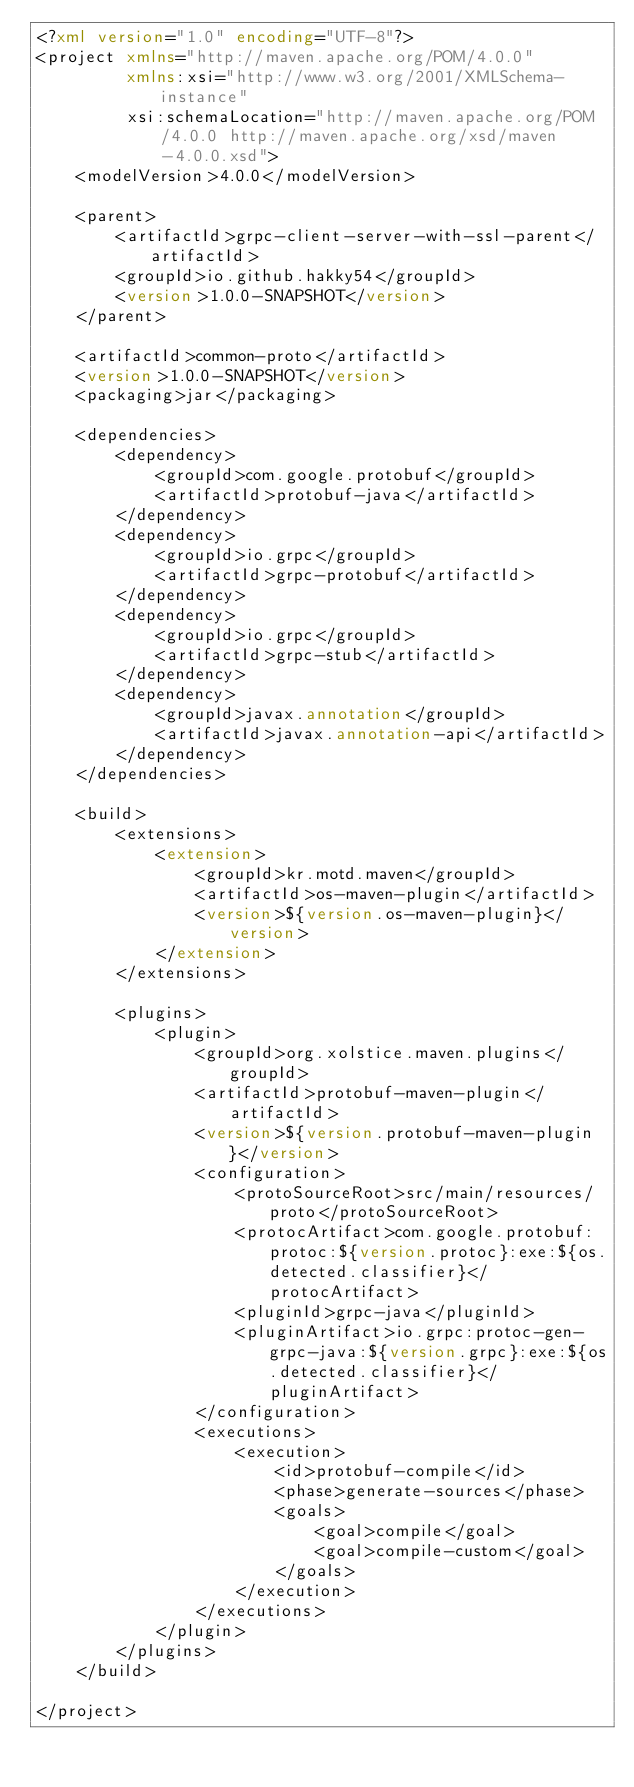Convert code to text. <code><loc_0><loc_0><loc_500><loc_500><_XML_><?xml version="1.0" encoding="UTF-8"?>
<project xmlns="http://maven.apache.org/POM/4.0.0"
         xmlns:xsi="http://www.w3.org/2001/XMLSchema-instance"
         xsi:schemaLocation="http://maven.apache.org/POM/4.0.0 http://maven.apache.org/xsd/maven-4.0.0.xsd">
    <modelVersion>4.0.0</modelVersion>

    <parent>
        <artifactId>grpc-client-server-with-ssl-parent</artifactId>
        <groupId>io.github.hakky54</groupId>
        <version>1.0.0-SNAPSHOT</version>
    </parent>

    <artifactId>common-proto</artifactId>
    <version>1.0.0-SNAPSHOT</version>
    <packaging>jar</packaging>

    <dependencies>
        <dependency>
            <groupId>com.google.protobuf</groupId>
            <artifactId>protobuf-java</artifactId>
        </dependency>
        <dependency>
            <groupId>io.grpc</groupId>
            <artifactId>grpc-protobuf</artifactId>
        </dependency>
        <dependency>
            <groupId>io.grpc</groupId>
            <artifactId>grpc-stub</artifactId>
        </dependency>
        <dependency>
            <groupId>javax.annotation</groupId>
            <artifactId>javax.annotation-api</artifactId>
        </dependency>
    </dependencies>

    <build>
        <extensions>
            <extension>
                <groupId>kr.motd.maven</groupId>
                <artifactId>os-maven-plugin</artifactId>
                <version>${version.os-maven-plugin}</version>
            </extension>
        </extensions>

        <plugins>
            <plugin>
                <groupId>org.xolstice.maven.plugins</groupId>
                <artifactId>protobuf-maven-plugin</artifactId>
                <version>${version.protobuf-maven-plugin}</version>
                <configuration>
                    <protoSourceRoot>src/main/resources/proto</protoSourceRoot>
                    <protocArtifact>com.google.protobuf:protoc:${version.protoc}:exe:${os.detected.classifier}</protocArtifact>
                    <pluginId>grpc-java</pluginId>
                    <pluginArtifact>io.grpc:protoc-gen-grpc-java:${version.grpc}:exe:${os.detected.classifier}</pluginArtifact>
                </configuration>
                <executions>
                    <execution>
                        <id>protobuf-compile</id>
                        <phase>generate-sources</phase>
                        <goals>
                            <goal>compile</goal>
                            <goal>compile-custom</goal>
                        </goals>
                    </execution>
                </executions>
            </plugin>
        </plugins>
    </build>

</project></code> 